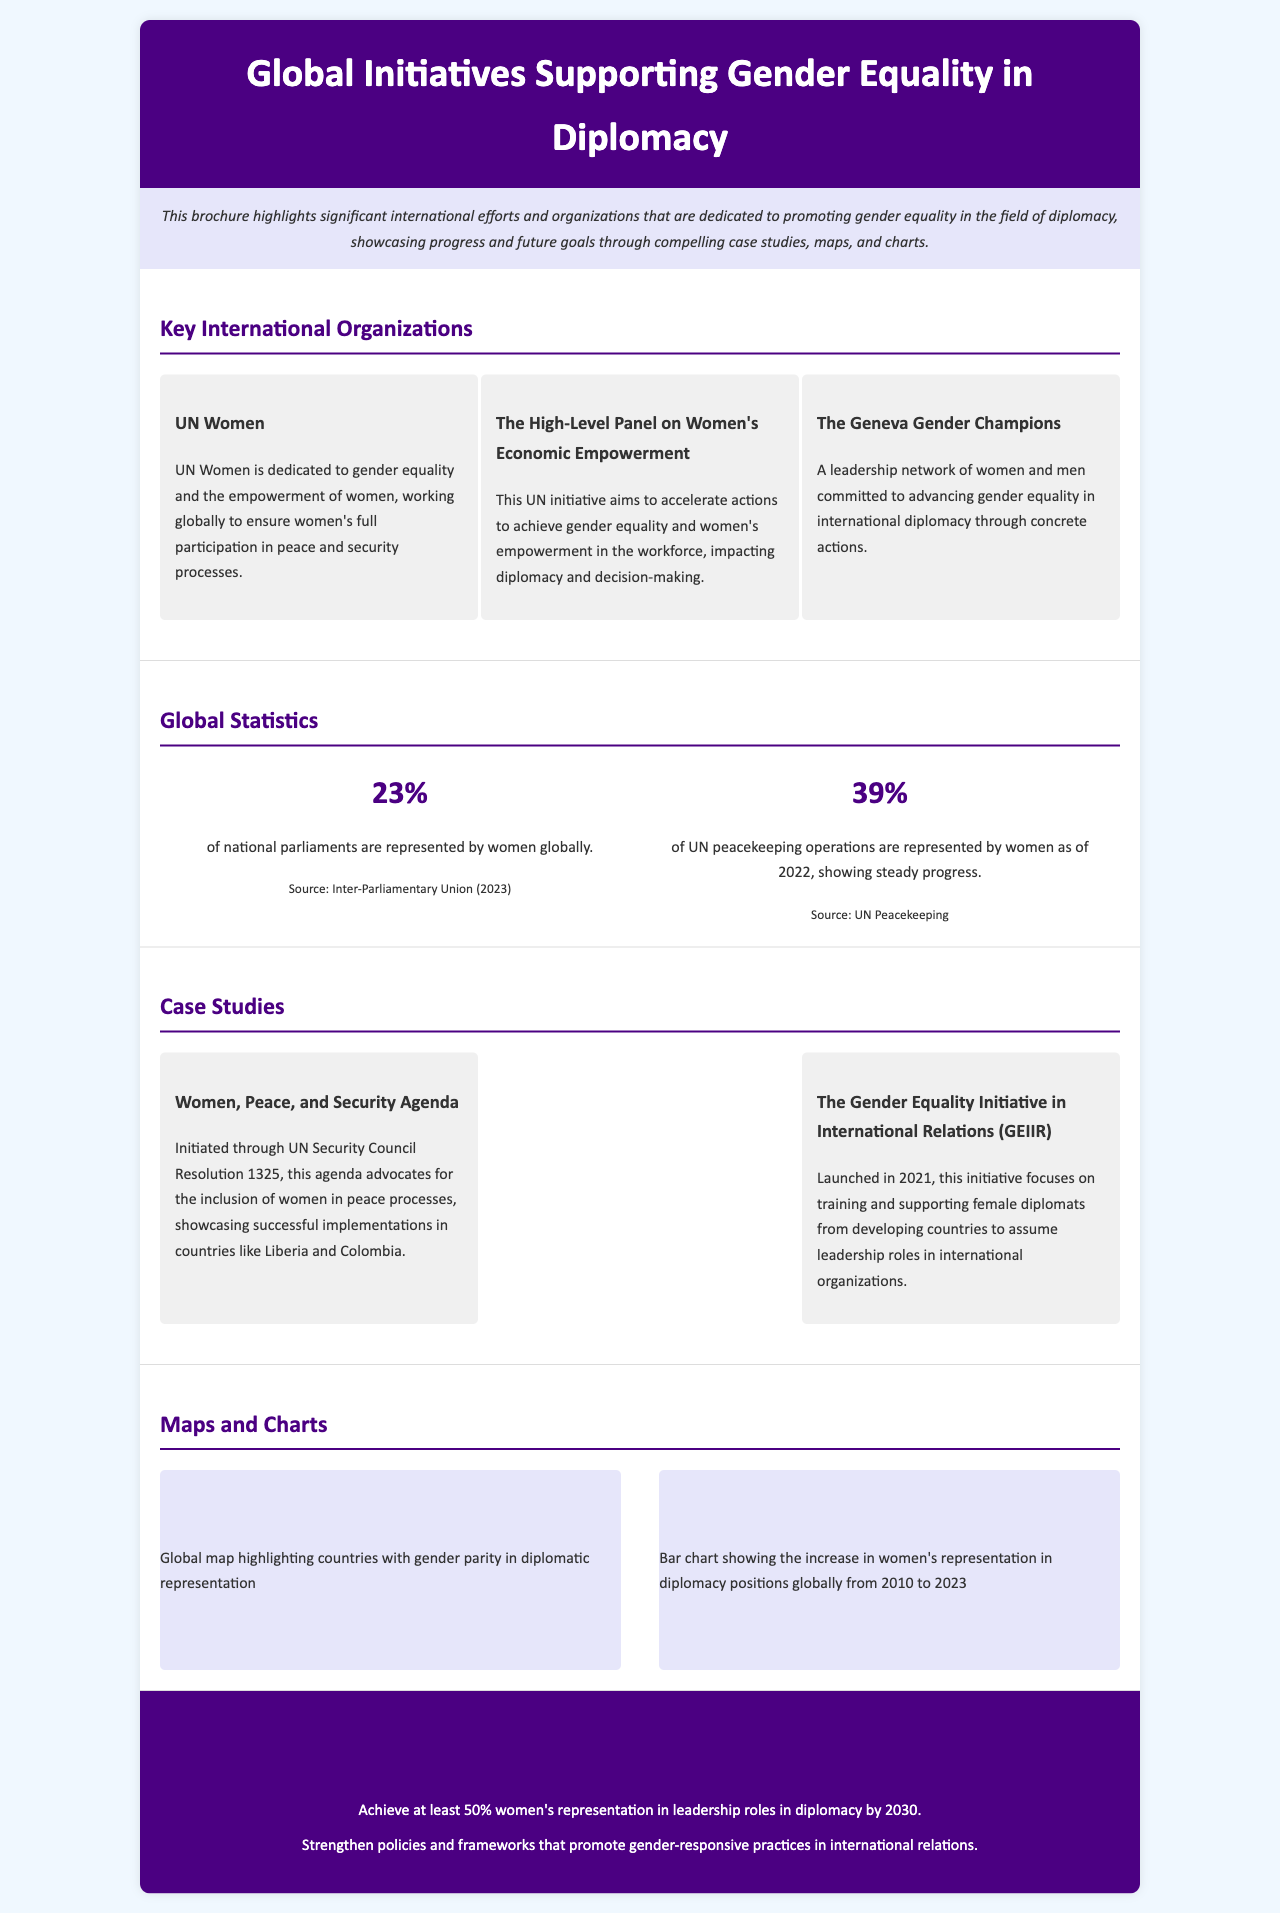what organization focuses on women's empowerment in peace processes? UN Women is the organization mentioned that is dedicated to ensuring women's full participation in peace and security processes.
Answer: UN Women what percentage of national parliaments are represented by women globally? The document states that 23% of national parliaments are represented by women globally.
Answer: 23% which initiative was launched in 2021 to support female diplomats? The Gender Equality Initiative in International Relations (GEIIR) is the initiative launched in 2021.
Answer: GEIIR what is the goal for women's leadership representation in diplomacy by 2030? The goal mentioned is to achieve at least 50% women's representation in leadership roles in diplomacy by 2030.
Answer: 50% what percentage of UN peacekeeping operations are represented by women as of 2022? The document indicates that 39% of UN peacekeeping operations are represented by women as of 2022.
Answer: 39% which agenda advocates for the inclusion of women in peace processes? The Women, Peace, and Security Agenda initiated through UN Security Council Resolution 1325 advocates for this inclusion.
Answer: Women, Peace, and Security Agenda what type of data visualizations are included in the brochure? The brochure includes a global map and a bar chart depicting women's representation in diplomacy positions.
Answer: Map and chart who are the Geneva Gender Champions? The Geneva Gender Champions are a leadership network committed to advancing gender equality in international diplomacy.
Answer: Leadership network what is the source for the statistics on women's representation? The source for the statistics mentioned is the Inter-Parliamentary Union for national parliaments and UN Peacekeeping for peacekeeping operations.
Answer: Inter-Parliamentary Union and UN Peacekeeping 